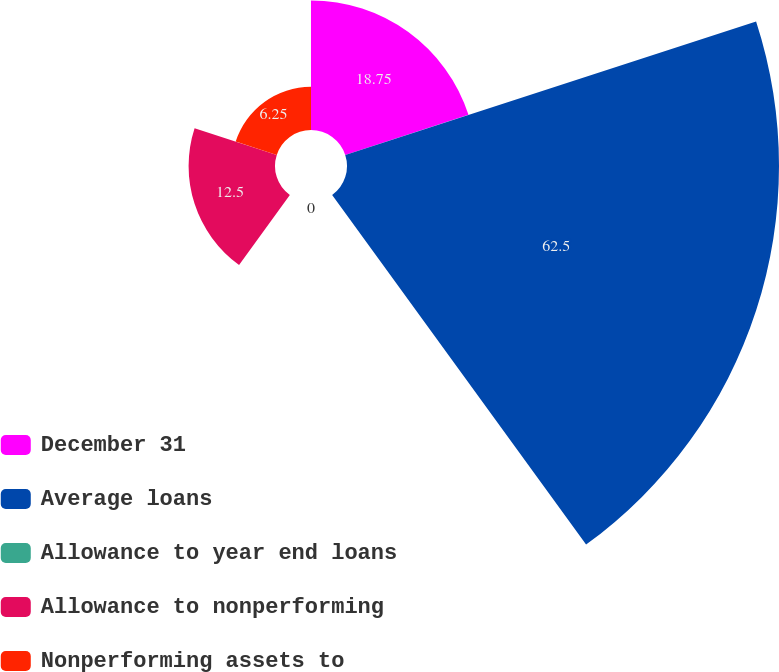Convert chart. <chart><loc_0><loc_0><loc_500><loc_500><pie_chart><fcel>December 31<fcel>Average loans<fcel>Allowance to year end loans<fcel>Allowance to nonperforming<fcel>Nonperforming assets to<nl><fcel>18.75%<fcel>62.5%<fcel>0.0%<fcel>12.5%<fcel>6.25%<nl></chart> 